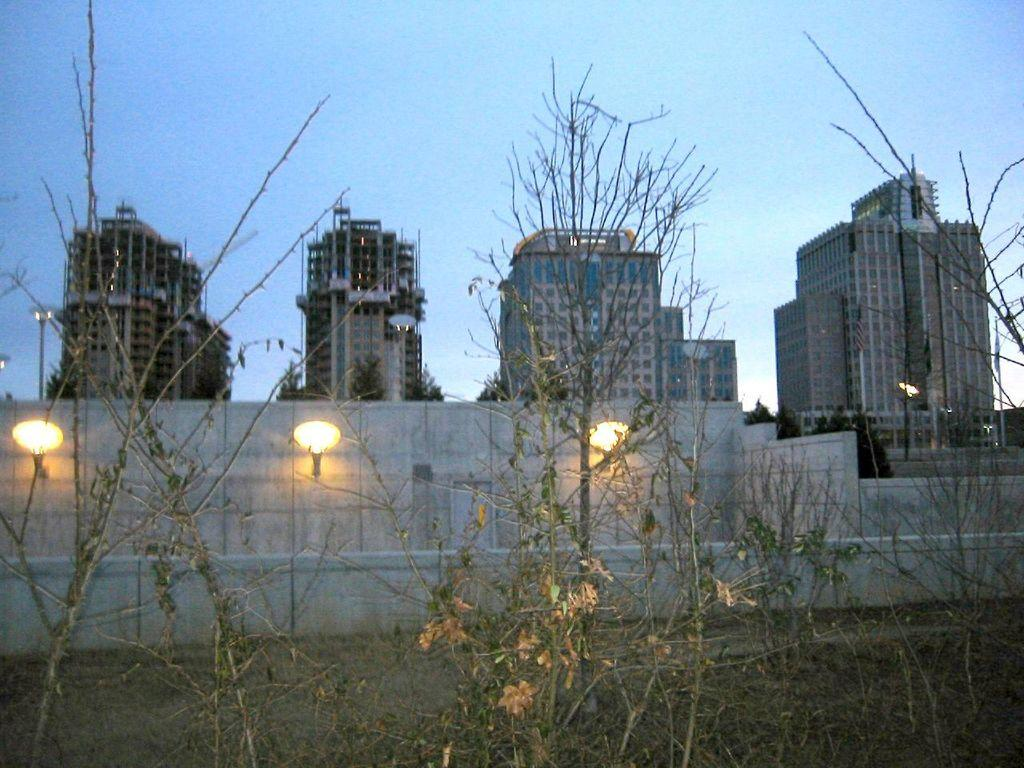What type of living organisms can be seen in the image? Plants and trees are visible in the image. What type of artificial light sources are present in the image? There are lights in the image. What type of structures can be seen in the image? There are buildings in the image. What type of barrier is present in the image? There is a wall in the image. What part of the natural environment is visible in the image? The sky is visible in the background of the image. What type of cheese is being used to solve the riddle in the image? There is no cheese or riddle present in the image. What type of place is depicted in the image? The image does not depict a specific place; it shows a combination of natural and man-made elements. 